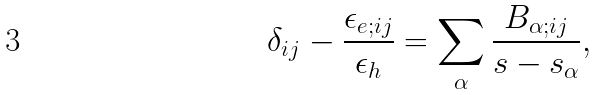Convert formula to latex. <formula><loc_0><loc_0><loc_500><loc_500>\delta _ { i j } - \frac { \epsilon _ { e ; i j } } { \epsilon _ { h } } = \sum _ { \alpha } \frac { B _ { \alpha ; i j } } { s - s _ { \alpha } } ,</formula> 